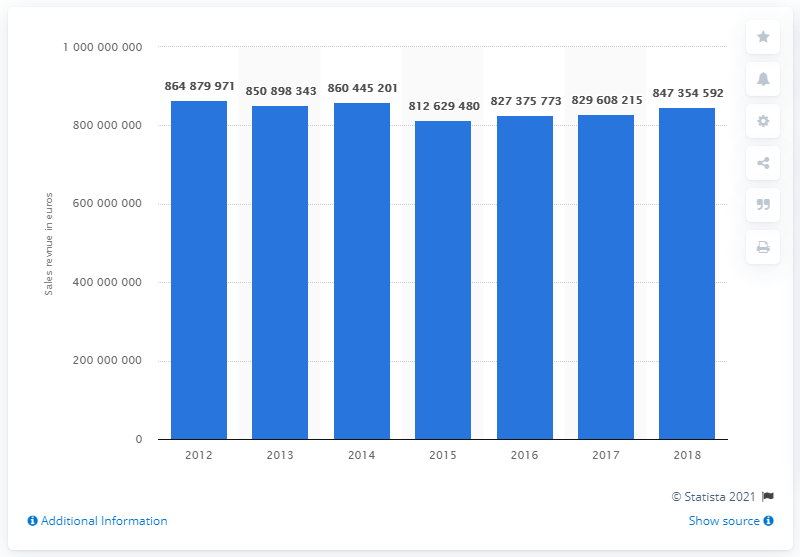Outline some significant characteristics in this image. ATAC's sales revenue in 2012 was 860,445,201. ATAC generated approximately 8.47354592 billion in revenue in 2018. 